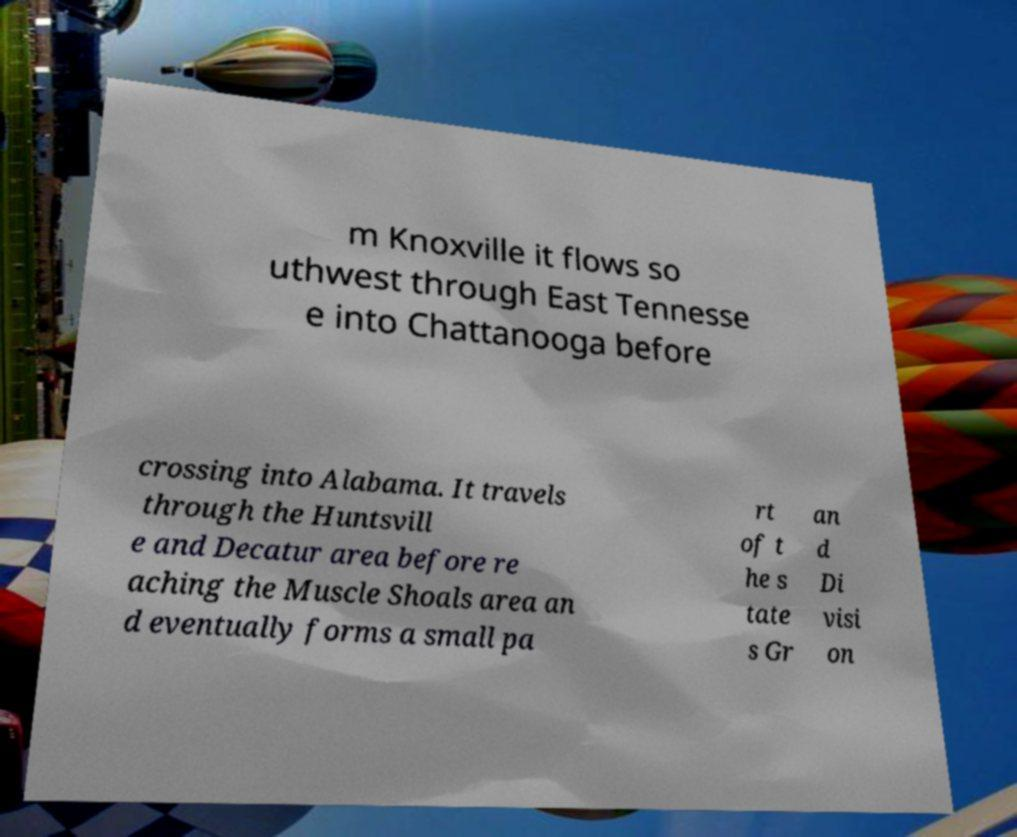There's text embedded in this image that I need extracted. Can you transcribe it verbatim? m Knoxville it flows so uthwest through East Tennesse e into Chattanooga before crossing into Alabama. It travels through the Huntsvill e and Decatur area before re aching the Muscle Shoals area an d eventually forms a small pa rt of t he s tate s Gr an d Di visi on 